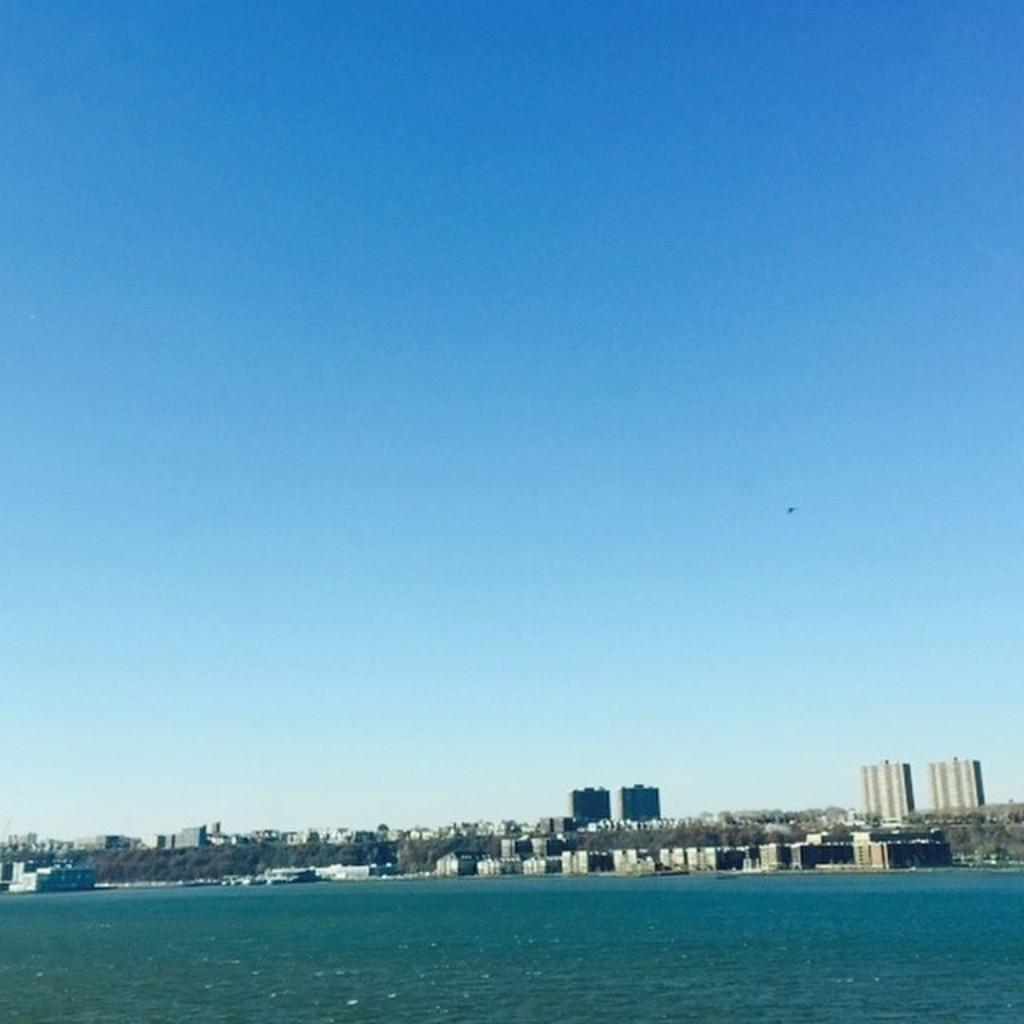What is located at the bottom of the image? There is water at the bottom of the image. What can be seen in the background of the image? There are buildings and trees in the background of the image. What is visible at the top of the image? The sky is visible at the top of the image. What type of square is present in the image? There is no square present in the image. How does the throat appear in the image? There is no throat visible in the image. 